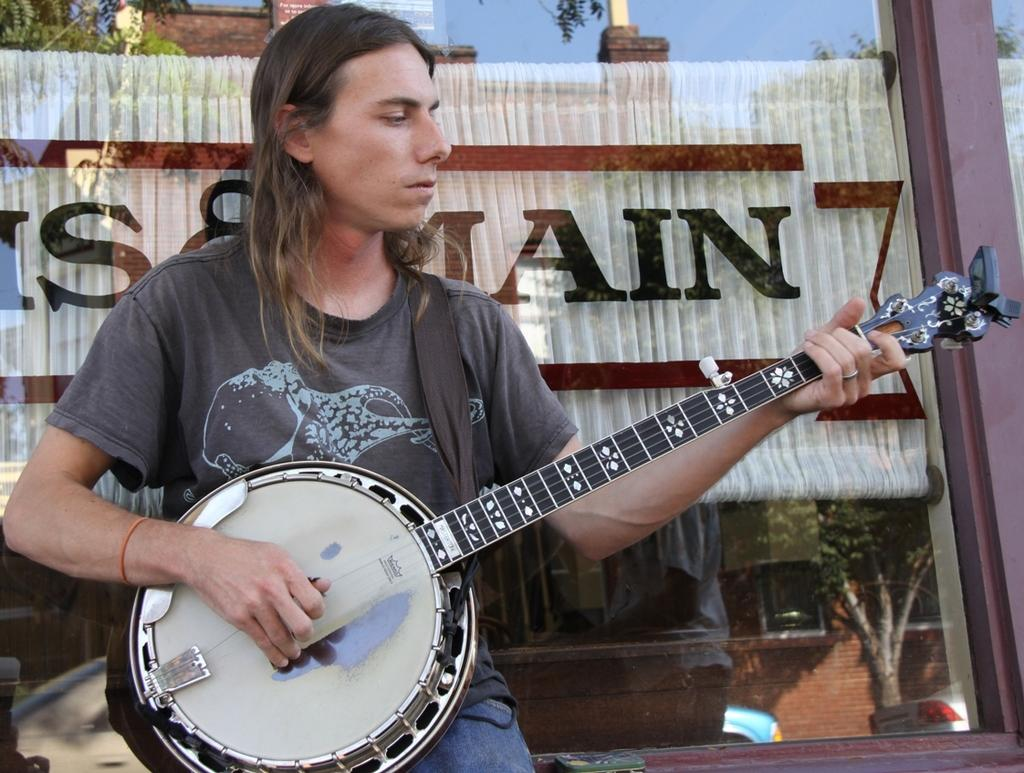Who is present in the image? There is a man in the image. What is the man wearing? The man is wearing a t-shirt. What is the man doing in the image? The man is sitting on a bench and holding a musical instrument. What can be seen in the background of the image? There is a wall in the background of the image. What type of scissors is the man using to cut the canvas in the image? There are no scissors or canvas present in the image; the man is holding a musical instrument and sitting on a bench. 